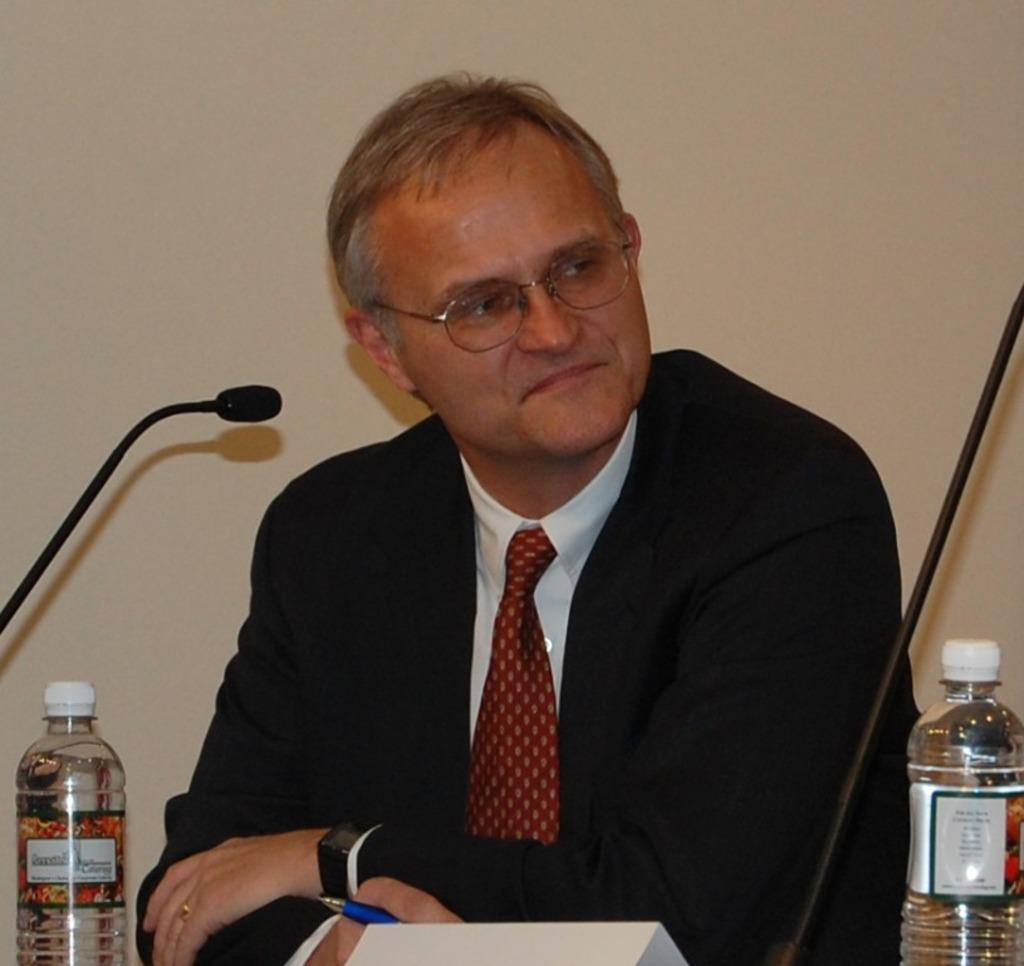Who is present in the image? There is a man in the image. What is the man wearing? The man is wearing a black blazer. What is the man doing in the image? The man is sitting on a chair. Where is the chair located in relation to the table? The chair is near a table. What items can be seen on the table? There are bottles and a microphone on the table. Can you tell me how many crows are sitting on the man's shoulder in the image? There are no crows present in the image; the man is sitting alone on the chair. 